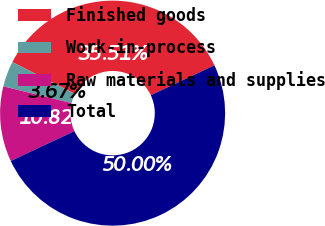Convert chart. <chart><loc_0><loc_0><loc_500><loc_500><pie_chart><fcel>Finished goods<fcel>Work-in-process<fcel>Raw materials and supplies<fcel>Total<nl><fcel>35.51%<fcel>3.67%<fcel>10.82%<fcel>50.0%<nl></chart> 